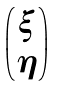Convert formula to latex. <formula><loc_0><loc_0><loc_500><loc_500>\begin{pmatrix} \xi \\ \eta \\ \end{pmatrix}</formula> 